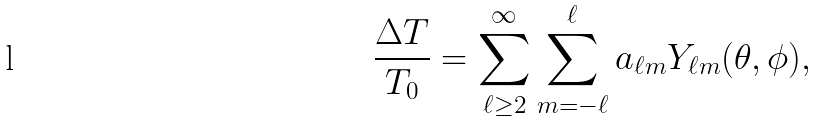<formula> <loc_0><loc_0><loc_500><loc_500>\frac { \Delta T } { T _ { 0 } } = \sum _ { \ell \geq 2 } ^ { \infty } \sum _ { m = - \ell } ^ { \ell } a _ { \ell m } Y _ { \ell m } ( \theta , \phi ) ,</formula> 